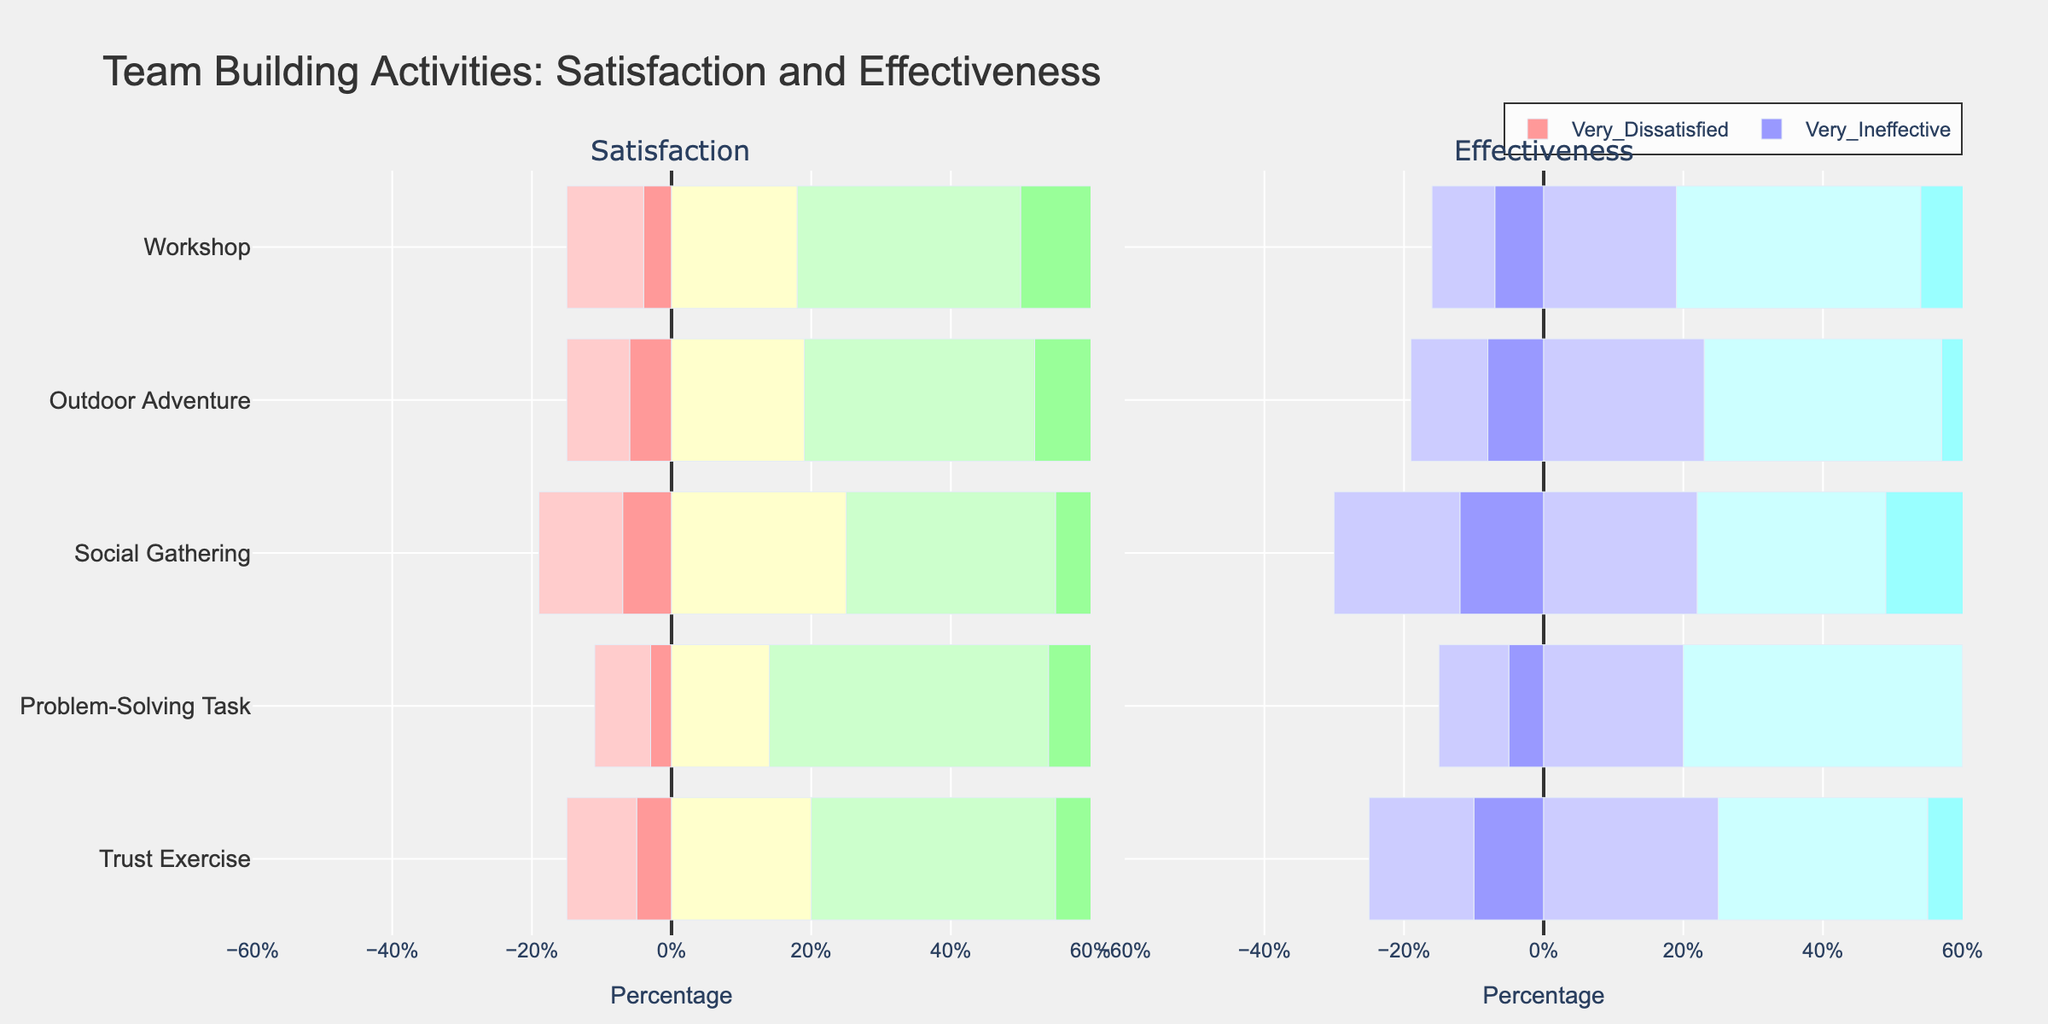What activity has the highest percentage of people who are very satisfied with it? The bar for "Very Satisfied" in the Satisfaction column is longest for the Workshop activity.
Answer: Workshop Which activity is perceived as the least effective? The sum of the bars for "Very Ineffective" and "Ineffective" in the Effectiveness column is highest for Social Gathering.
Answer: Social Gathering What is the combined percentage of people who are satisfied or very satisfied with the Trust Exercise activity? The bar for "Satisfied" (35) plus the bar for "Very Satisfied" (30) in the Satisfaction column for Trust Exercise equals 65.
Answer: 65% Which activity has the smallest difference between total satisfied (Satisfied + Very Satisfied) and total dissatisfied (Very Dissatisfied + Dissatisfied) percentages? Calculate the difference for each activity: 
  - Trust Exercise: (35+30) - (5+10) = 50
  - Problem-Solving Task: (40+35) - (3+8) = 64
  - Social Gathering: (30+26) - (7+12) = 37
  - Outdoor Adventure: (33+33) - (6+9) = 51
  - Workshop: (32+35) - (4+11) = 52
  Social Gathering has the smallest difference of 37.
Answer: Social Gathering Which activity has the highest combined percentage of people who rated it neutral in terms of satisfaction and effectiveness? Find the sum of "Neutral" bars in both Satisfaction and Effectiveness columns:
  - Trust Exercise: 20 + 25 = 45
  - Problem-Solving Task: 14 + 20 = 34
  - Social Gathering: 25 + 22 = 47
  - Outdoor Adventure: 19 + 23 = 42
  - Workshop: 18 + 19 = 37
  Social Gathering has the highest combined percentage of 47.
Answer: Social Gathering Which activity has the highest combined percentage of effective (Effective + Very Effective) ratings? Calculate the sum of "Effective" and "Very Effective" bars in the Effectiveness column for each activity:
  - Trust Exercise: 30 + 20 = 50
  - Problem-Solving Task: 40 + 25 = 65
  - Social Gathering: 27 + 21 = 48
  - Outdoor Adventure: 34 + 24 = 58
  - Workshop: 35 + 30 = 65
  Both Problem-Solving Task and Workshop have the highest combined percentage of 65.
Answer: Problem-Solving Task and Workshop By how much does the percentage of people who found the Workshop very effective exceed those who found the Trust Exercise very effective? Subtract the "Very Effective" value for Trust Exercise (20) from the "Very Effective" value for Workshop (30).
Answer: 10% Which activity shows the least variability in satisfaction ratings (smallest range between highest and lowest)? The range is calculated by subtracting the minimal value from the maximum value in the Satisfaction column for each activity. 
  - Trust Exercise: 30 - 5 = 25
  - Problem-Solving Task: 35 - 3 = 32
  - Social Gathering: 26 - 7 = 19
  - Outdoor Adventure: 33 - 6 = 27
  - Workshop: 35 - 4 = 31
  Social Gathering has the smallest range of 19.
Answer: Social Gathering Which activity do more people rate as "Neutral" rather than "Very Effective" in terms of effectiveness? Compare the heights of the "Neutral" and "Very Effective" bars in the Effectiveness column:
  - Trust Exercise: Neutral (25) > Very Effective (20)
  - Problem-Solving Task: Neutral (20) < Very Effective (25)
  - Social Gathering: Neutral (22) > Very Effective (21)
  - Outdoor Adventure: Neutral (23) < Very Effective (24)
  - Workshop: Neutral (19) < Very Effective (30)
  Both Trust Exercise and Social Gathering have more people rating it as "Neutral" than "Very Effective".
Answer: Trust Exercise and Social Gathering 